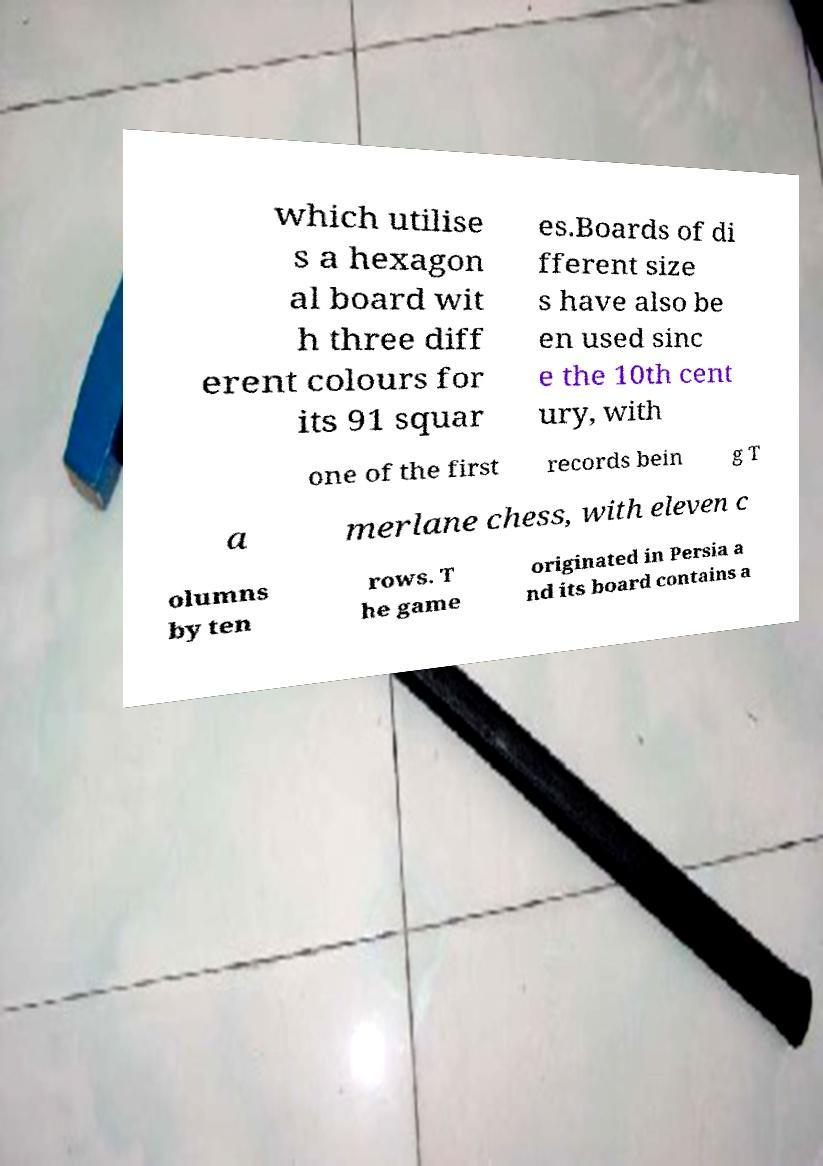Can you accurately transcribe the text from the provided image for me? which utilise s a hexagon al board wit h three diff erent colours for its 91 squar es.Boards of di fferent size s have also be en used sinc e the 10th cent ury, with one of the first records bein g T a merlane chess, with eleven c olumns by ten rows. T he game originated in Persia a nd its board contains a 